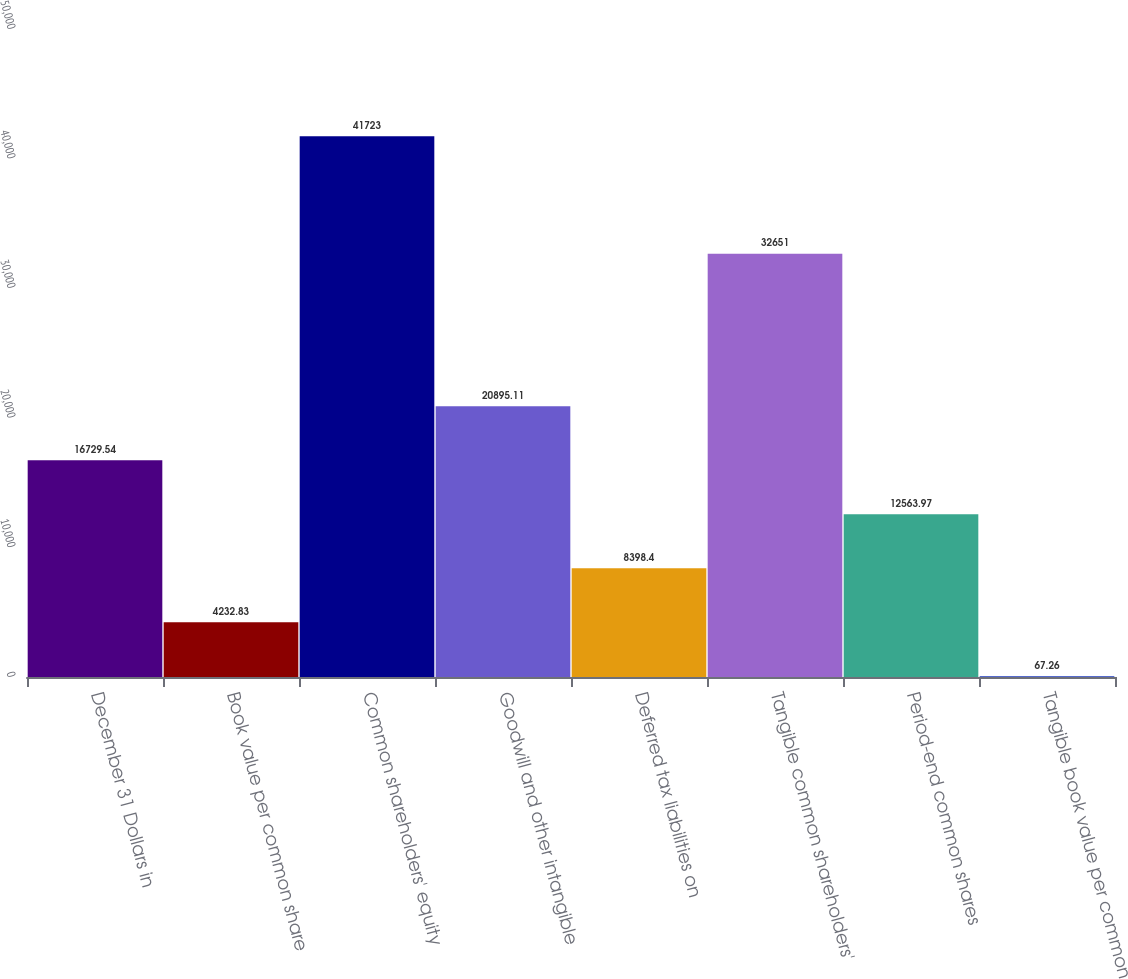Convert chart. <chart><loc_0><loc_0><loc_500><loc_500><bar_chart><fcel>December 31 Dollars in<fcel>Book value per common share<fcel>Common shareholders' equity<fcel>Goodwill and other intangible<fcel>Deferred tax liabilities on<fcel>Tangible common shareholders'<fcel>Period-end common shares<fcel>Tangible book value per common<nl><fcel>16729.5<fcel>4232.83<fcel>41723<fcel>20895.1<fcel>8398.4<fcel>32651<fcel>12564<fcel>67.26<nl></chart> 